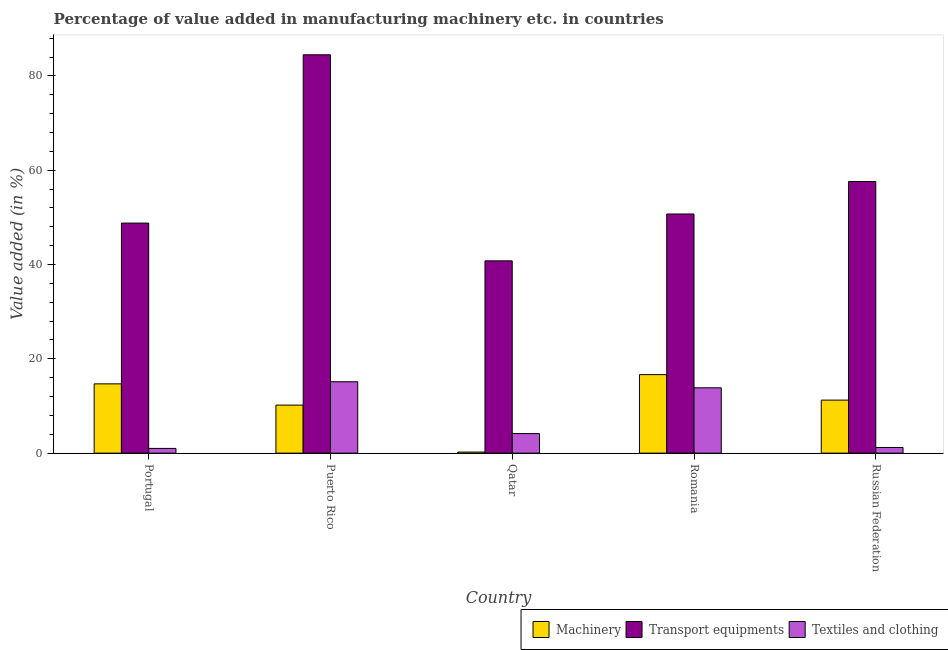How many different coloured bars are there?
Offer a terse response. 3. How many groups of bars are there?
Provide a short and direct response. 5. How many bars are there on the 3rd tick from the left?
Provide a short and direct response. 3. What is the label of the 2nd group of bars from the left?
Provide a short and direct response. Puerto Rico. What is the value added in manufacturing machinery in Russian Federation?
Offer a terse response. 11.25. Across all countries, what is the maximum value added in manufacturing machinery?
Your answer should be compact. 16.65. Across all countries, what is the minimum value added in manufacturing transport equipments?
Provide a short and direct response. 40.78. In which country was the value added in manufacturing textile and clothing maximum?
Your answer should be very brief. Puerto Rico. In which country was the value added in manufacturing transport equipments minimum?
Your answer should be very brief. Qatar. What is the total value added in manufacturing machinery in the graph?
Offer a very short reply. 53.01. What is the difference between the value added in manufacturing machinery in Puerto Rico and that in Russian Federation?
Give a very brief answer. -1.06. What is the difference between the value added in manufacturing machinery in Romania and the value added in manufacturing textile and clothing in Russian Federation?
Offer a terse response. 15.45. What is the average value added in manufacturing textile and clothing per country?
Ensure brevity in your answer.  7.07. What is the difference between the value added in manufacturing machinery and value added in manufacturing transport equipments in Qatar?
Your answer should be very brief. -40.56. What is the ratio of the value added in manufacturing textile and clothing in Romania to that in Russian Federation?
Make the answer very short. 11.52. What is the difference between the highest and the second highest value added in manufacturing textile and clothing?
Ensure brevity in your answer.  1.29. What is the difference between the highest and the lowest value added in manufacturing textile and clothing?
Your answer should be very brief. 14.14. In how many countries, is the value added in manufacturing transport equipments greater than the average value added in manufacturing transport equipments taken over all countries?
Provide a succinct answer. 2. What does the 1st bar from the left in Puerto Rico represents?
Keep it short and to the point. Machinery. What does the 3rd bar from the right in Russian Federation represents?
Ensure brevity in your answer.  Machinery. How many bars are there?
Ensure brevity in your answer.  15. What is the difference between two consecutive major ticks on the Y-axis?
Offer a very short reply. 20. Are the values on the major ticks of Y-axis written in scientific E-notation?
Give a very brief answer. No. Does the graph contain any zero values?
Make the answer very short. No. Does the graph contain grids?
Your response must be concise. No. How many legend labels are there?
Offer a very short reply. 3. How are the legend labels stacked?
Keep it short and to the point. Horizontal. What is the title of the graph?
Make the answer very short. Percentage of value added in manufacturing machinery etc. in countries. What is the label or title of the Y-axis?
Your answer should be compact. Value added (in %). What is the Value added (in %) of Machinery in Portugal?
Give a very brief answer. 14.69. What is the Value added (in %) of Transport equipments in Portugal?
Offer a terse response. 48.79. What is the Value added (in %) in Textiles and clothing in Portugal?
Offer a very short reply. 1. What is the Value added (in %) in Machinery in Puerto Rico?
Give a very brief answer. 10.19. What is the Value added (in %) of Transport equipments in Puerto Rico?
Your answer should be very brief. 84.49. What is the Value added (in %) in Textiles and clothing in Puerto Rico?
Offer a terse response. 15.14. What is the Value added (in %) of Machinery in Qatar?
Offer a very short reply. 0.23. What is the Value added (in %) of Transport equipments in Qatar?
Make the answer very short. 40.78. What is the Value added (in %) in Textiles and clothing in Qatar?
Your answer should be very brief. 4.15. What is the Value added (in %) of Machinery in Romania?
Your answer should be very brief. 16.65. What is the Value added (in %) of Transport equipments in Romania?
Keep it short and to the point. 50.72. What is the Value added (in %) in Textiles and clothing in Romania?
Give a very brief answer. 13.86. What is the Value added (in %) in Machinery in Russian Federation?
Give a very brief answer. 11.25. What is the Value added (in %) in Transport equipments in Russian Federation?
Your answer should be compact. 57.6. What is the Value added (in %) of Textiles and clothing in Russian Federation?
Make the answer very short. 1.2. Across all countries, what is the maximum Value added (in %) in Machinery?
Make the answer very short. 16.65. Across all countries, what is the maximum Value added (in %) of Transport equipments?
Provide a short and direct response. 84.49. Across all countries, what is the maximum Value added (in %) in Textiles and clothing?
Provide a short and direct response. 15.14. Across all countries, what is the minimum Value added (in %) of Machinery?
Keep it short and to the point. 0.23. Across all countries, what is the minimum Value added (in %) in Transport equipments?
Ensure brevity in your answer.  40.78. Across all countries, what is the minimum Value added (in %) of Textiles and clothing?
Offer a terse response. 1. What is the total Value added (in %) in Machinery in the graph?
Provide a short and direct response. 53.01. What is the total Value added (in %) in Transport equipments in the graph?
Give a very brief answer. 282.39. What is the total Value added (in %) in Textiles and clothing in the graph?
Your answer should be compact. 35.35. What is the difference between the Value added (in %) in Machinery in Portugal and that in Puerto Rico?
Offer a terse response. 4.51. What is the difference between the Value added (in %) of Transport equipments in Portugal and that in Puerto Rico?
Provide a succinct answer. -35.69. What is the difference between the Value added (in %) of Textiles and clothing in Portugal and that in Puerto Rico?
Provide a succinct answer. -14.14. What is the difference between the Value added (in %) in Machinery in Portugal and that in Qatar?
Provide a succinct answer. 14.46. What is the difference between the Value added (in %) of Transport equipments in Portugal and that in Qatar?
Provide a short and direct response. 8.01. What is the difference between the Value added (in %) of Textiles and clothing in Portugal and that in Qatar?
Give a very brief answer. -3.15. What is the difference between the Value added (in %) in Machinery in Portugal and that in Romania?
Your response must be concise. -1.96. What is the difference between the Value added (in %) of Transport equipments in Portugal and that in Romania?
Offer a very short reply. -1.93. What is the difference between the Value added (in %) in Textiles and clothing in Portugal and that in Romania?
Offer a terse response. -12.85. What is the difference between the Value added (in %) in Machinery in Portugal and that in Russian Federation?
Give a very brief answer. 3.45. What is the difference between the Value added (in %) of Transport equipments in Portugal and that in Russian Federation?
Keep it short and to the point. -8.81. What is the difference between the Value added (in %) in Textiles and clothing in Portugal and that in Russian Federation?
Make the answer very short. -0.2. What is the difference between the Value added (in %) of Machinery in Puerto Rico and that in Qatar?
Your answer should be compact. 9.96. What is the difference between the Value added (in %) of Transport equipments in Puerto Rico and that in Qatar?
Provide a short and direct response. 43.7. What is the difference between the Value added (in %) in Textiles and clothing in Puerto Rico and that in Qatar?
Make the answer very short. 10.99. What is the difference between the Value added (in %) of Machinery in Puerto Rico and that in Romania?
Offer a very short reply. -6.47. What is the difference between the Value added (in %) of Transport equipments in Puerto Rico and that in Romania?
Your answer should be very brief. 33.76. What is the difference between the Value added (in %) of Textiles and clothing in Puerto Rico and that in Romania?
Ensure brevity in your answer.  1.29. What is the difference between the Value added (in %) of Machinery in Puerto Rico and that in Russian Federation?
Provide a short and direct response. -1.06. What is the difference between the Value added (in %) in Transport equipments in Puerto Rico and that in Russian Federation?
Provide a short and direct response. 26.88. What is the difference between the Value added (in %) of Textiles and clothing in Puerto Rico and that in Russian Federation?
Your answer should be very brief. 13.94. What is the difference between the Value added (in %) in Machinery in Qatar and that in Romania?
Make the answer very short. -16.43. What is the difference between the Value added (in %) in Transport equipments in Qatar and that in Romania?
Your answer should be very brief. -9.94. What is the difference between the Value added (in %) of Textiles and clothing in Qatar and that in Romania?
Provide a short and direct response. -9.71. What is the difference between the Value added (in %) of Machinery in Qatar and that in Russian Federation?
Offer a terse response. -11.02. What is the difference between the Value added (in %) of Transport equipments in Qatar and that in Russian Federation?
Offer a terse response. -16.82. What is the difference between the Value added (in %) of Textiles and clothing in Qatar and that in Russian Federation?
Offer a terse response. 2.95. What is the difference between the Value added (in %) of Machinery in Romania and that in Russian Federation?
Your response must be concise. 5.41. What is the difference between the Value added (in %) of Transport equipments in Romania and that in Russian Federation?
Offer a very short reply. -6.88. What is the difference between the Value added (in %) in Textiles and clothing in Romania and that in Russian Federation?
Provide a succinct answer. 12.65. What is the difference between the Value added (in %) of Machinery in Portugal and the Value added (in %) of Transport equipments in Puerto Rico?
Your answer should be very brief. -69.79. What is the difference between the Value added (in %) of Machinery in Portugal and the Value added (in %) of Textiles and clothing in Puerto Rico?
Offer a very short reply. -0.45. What is the difference between the Value added (in %) in Transport equipments in Portugal and the Value added (in %) in Textiles and clothing in Puerto Rico?
Your answer should be very brief. 33.65. What is the difference between the Value added (in %) of Machinery in Portugal and the Value added (in %) of Transport equipments in Qatar?
Your response must be concise. -26.09. What is the difference between the Value added (in %) of Machinery in Portugal and the Value added (in %) of Textiles and clothing in Qatar?
Make the answer very short. 10.54. What is the difference between the Value added (in %) in Transport equipments in Portugal and the Value added (in %) in Textiles and clothing in Qatar?
Your response must be concise. 44.64. What is the difference between the Value added (in %) in Machinery in Portugal and the Value added (in %) in Transport equipments in Romania?
Your response must be concise. -36.03. What is the difference between the Value added (in %) of Machinery in Portugal and the Value added (in %) of Textiles and clothing in Romania?
Give a very brief answer. 0.84. What is the difference between the Value added (in %) in Transport equipments in Portugal and the Value added (in %) in Textiles and clothing in Romania?
Provide a succinct answer. 34.93. What is the difference between the Value added (in %) in Machinery in Portugal and the Value added (in %) in Transport equipments in Russian Federation?
Provide a short and direct response. -42.91. What is the difference between the Value added (in %) in Machinery in Portugal and the Value added (in %) in Textiles and clothing in Russian Federation?
Ensure brevity in your answer.  13.49. What is the difference between the Value added (in %) in Transport equipments in Portugal and the Value added (in %) in Textiles and clothing in Russian Federation?
Provide a short and direct response. 47.59. What is the difference between the Value added (in %) in Machinery in Puerto Rico and the Value added (in %) in Transport equipments in Qatar?
Your answer should be compact. -30.6. What is the difference between the Value added (in %) of Machinery in Puerto Rico and the Value added (in %) of Textiles and clothing in Qatar?
Make the answer very short. 6.04. What is the difference between the Value added (in %) of Transport equipments in Puerto Rico and the Value added (in %) of Textiles and clothing in Qatar?
Your answer should be compact. 80.34. What is the difference between the Value added (in %) of Machinery in Puerto Rico and the Value added (in %) of Transport equipments in Romania?
Offer a terse response. -40.53. What is the difference between the Value added (in %) in Machinery in Puerto Rico and the Value added (in %) in Textiles and clothing in Romania?
Offer a terse response. -3.67. What is the difference between the Value added (in %) in Transport equipments in Puerto Rico and the Value added (in %) in Textiles and clothing in Romania?
Your answer should be very brief. 70.63. What is the difference between the Value added (in %) of Machinery in Puerto Rico and the Value added (in %) of Transport equipments in Russian Federation?
Offer a very short reply. -47.42. What is the difference between the Value added (in %) of Machinery in Puerto Rico and the Value added (in %) of Textiles and clothing in Russian Federation?
Provide a short and direct response. 8.98. What is the difference between the Value added (in %) of Transport equipments in Puerto Rico and the Value added (in %) of Textiles and clothing in Russian Federation?
Make the answer very short. 83.28. What is the difference between the Value added (in %) in Machinery in Qatar and the Value added (in %) in Transport equipments in Romania?
Provide a succinct answer. -50.49. What is the difference between the Value added (in %) in Machinery in Qatar and the Value added (in %) in Textiles and clothing in Romania?
Make the answer very short. -13.63. What is the difference between the Value added (in %) of Transport equipments in Qatar and the Value added (in %) of Textiles and clothing in Romania?
Your response must be concise. 26.93. What is the difference between the Value added (in %) of Machinery in Qatar and the Value added (in %) of Transport equipments in Russian Federation?
Your answer should be compact. -57.38. What is the difference between the Value added (in %) of Machinery in Qatar and the Value added (in %) of Textiles and clothing in Russian Federation?
Provide a succinct answer. -0.97. What is the difference between the Value added (in %) of Transport equipments in Qatar and the Value added (in %) of Textiles and clothing in Russian Federation?
Offer a terse response. 39.58. What is the difference between the Value added (in %) of Machinery in Romania and the Value added (in %) of Transport equipments in Russian Federation?
Your response must be concise. -40.95. What is the difference between the Value added (in %) of Machinery in Romania and the Value added (in %) of Textiles and clothing in Russian Federation?
Your answer should be very brief. 15.45. What is the difference between the Value added (in %) in Transport equipments in Romania and the Value added (in %) in Textiles and clothing in Russian Federation?
Your answer should be compact. 49.52. What is the average Value added (in %) in Machinery per country?
Keep it short and to the point. 10.6. What is the average Value added (in %) of Transport equipments per country?
Provide a succinct answer. 56.48. What is the average Value added (in %) in Textiles and clothing per country?
Your answer should be very brief. 7.07. What is the difference between the Value added (in %) in Machinery and Value added (in %) in Transport equipments in Portugal?
Your answer should be compact. -34.1. What is the difference between the Value added (in %) in Machinery and Value added (in %) in Textiles and clothing in Portugal?
Offer a very short reply. 13.69. What is the difference between the Value added (in %) of Transport equipments and Value added (in %) of Textiles and clothing in Portugal?
Provide a succinct answer. 47.79. What is the difference between the Value added (in %) of Machinery and Value added (in %) of Transport equipments in Puerto Rico?
Your response must be concise. -74.3. What is the difference between the Value added (in %) of Machinery and Value added (in %) of Textiles and clothing in Puerto Rico?
Your answer should be very brief. -4.95. What is the difference between the Value added (in %) in Transport equipments and Value added (in %) in Textiles and clothing in Puerto Rico?
Offer a very short reply. 69.34. What is the difference between the Value added (in %) in Machinery and Value added (in %) in Transport equipments in Qatar?
Offer a terse response. -40.56. What is the difference between the Value added (in %) of Machinery and Value added (in %) of Textiles and clothing in Qatar?
Your response must be concise. -3.92. What is the difference between the Value added (in %) of Transport equipments and Value added (in %) of Textiles and clothing in Qatar?
Offer a very short reply. 36.64. What is the difference between the Value added (in %) in Machinery and Value added (in %) in Transport equipments in Romania?
Provide a short and direct response. -34.07. What is the difference between the Value added (in %) of Machinery and Value added (in %) of Textiles and clothing in Romania?
Provide a short and direct response. 2.8. What is the difference between the Value added (in %) of Transport equipments and Value added (in %) of Textiles and clothing in Romania?
Make the answer very short. 36.87. What is the difference between the Value added (in %) in Machinery and Value added (in %) in Transport equipments in Russian Federation?
Make the answer very short. -46.36. What is the difference between the Value added (in %) of Machinery and Value added (in %) of Textiles and clothing in Russian Federation?
Offer a terse response. 10.04. What is the difference between the Value added (in %) of Transport equipments and Value added (in %) of Textiles and clothing in Russian Federation?
Offer a terse response. 56.4. What is the ratio of the Value added (in %) of Machinery in Portugal to that in Puerto Rico?
Provide a succinct answer. 1.44. What is the ratio of the Value added (in %) of Transport equipments in Portugal to that in Puerto Rico?
Your answer should be compact. 0.58. What is the ratio of the Value added (in %) in Textiles and clothing in Portugal to that in Puerto Rico?
Ensure brevity in your answer.  0.07. What is the ratio of the Value added (in %) of Machinery in Portugal to that in Qatar?
Give a very brief answer. 64.37. What is the ratio of the Value added (in %) of Transport equipments in Portugal to that in Qatar?
Keep it short and to the point. 1.2. What is the ratio of the Value added (in %) of Textiles and clothing in Portugal to that in Qatar?
Provide a short and direct response. 0.24. What is the ratio of the Value added (in %) in Machinery in Portugal to that in Romania?
Offer a very short reply. 0.88. What is the ratio of the Value added (in %) of Transport equipments in Portugal to that in Romania?
Make the answer very short. 0.96. What is the ratio of the Value added (in %) in Textiles and clothing in Portugal to that in Romania?
Provide a succinct answer. 0.07. What is the ratio of the Value added (in %) in Machinery in Portugal to that in Russian Federation?
Ensure brevity in your answer.  1.31. What is the ratio of the Value added (in %) in Transport equipments in Portugal to that in Russian Federation?
Keep it short and to the point. 0.85. What is the ratio of the Value added (in %) in Textiles and clothing in Portugal to that in Russian Federation?
Your response must be concise. 0.83. What is the ratio of the Value added (in %) of Machinery in Puerto Rico to that in Qatar?
Your answer should be very brief. 44.63. What is the ratio of the Value added (in %) in Transport equipments in Puerto Rico to that in Qatar?
Give a very brief answer. 2.07. What is the ratio of the Value added (in %) in Textiles and clothing in Puerto Rico to that in Qatar?
Your answer should be compact. 3.65. What is the ratio of the Value added (in %) of Machinery in Puerto Rico to that in Romania?
Give a very brief answer. 0.61. What is the ratio of the Value added (in %) of Transport equipments in Puerto Rico to that in Romania?
Provide a succinct answer. 1.67. What is the ratio of the Value added (in %) of Textiles and clothing in Puerto Rico to that in Romania?
Offer a terse response. 1.09. What is the ratio of the Value added (in %) of Machinery in Puerto Rico to that in Russian Federation?
Keep it short and to the point. 0.91. What is the ratio of the Value added (in %) of Transport equipments in Puerto Rico to that in Russian Federation?
Provide a short and direct response. 1.47. What is the ratio of the Value added (in %) of Textiles and clothing in Puerto Rico to that in Russian Federation?
Make the answer very short. 12.59. What is the ratio of the Value added (in %) of Machinery in Qatar to that in Romania?
Make the answer very short. 0.01. What is the ratio of the Value added (in %) of Transport equipments in Qatar to that in Romania?
Make the answer very short. 0.8. What is the ratio of the Value added (in %) in Textiles and clothing in Qatar to that in Romania?
Provide a succinct answer. 0.3. What is the ratio of the Value added (in %) in Machinery in Qatar to that in Russian Federation?
Keep it short and to the point. 0.02. What is the ratio of the Value added (in %) of Transport equipments in Qatar to that in Russian Federation?
Offer a very short reply. 0.71. What is the ratio of the Value added (in %) of Textiles and clothing in Qatar to that in Russian Federation?
Offer a very short reply. 3.45. What is the ratio of the Value added (in %) in Machinery in Romania to that in Russian Federation?
Offer a terse response. 1.48. What is the ratio of the Value added (in %) in Transport equipments in Romania to that in Russian Federation?
Offer a terse response. 0.88. What is the ratio of the Value added (in %) in Textiles and clothing in Romania to that in Russian Federation?
Give a very brief answer. 11.52. What is the difference between the highest and the second highest Value added (in %) in Machinery?
Your response must be concise. 1.96. What is the difference between the highest and the second highest Value added (in %) in Transport equipments?
Give a very brief answer. 26.88. What is the difference between the highest and the second highest Value added (in %) in Textiles and clothing?
Make the answer very short. 1.29. What is the difference between the highest and the lowest Value added (in %) in Machinery?
Provide a short and direct response. 16.43. What is the difference between the highest and the lowest Value added (in %) in Transport equipments?
Your answer should be compact. 43.7. What is the difference between the highest and the lowest Value added (in %) of Textiles and clothing?
Keep it short and to the point. 14.14. 